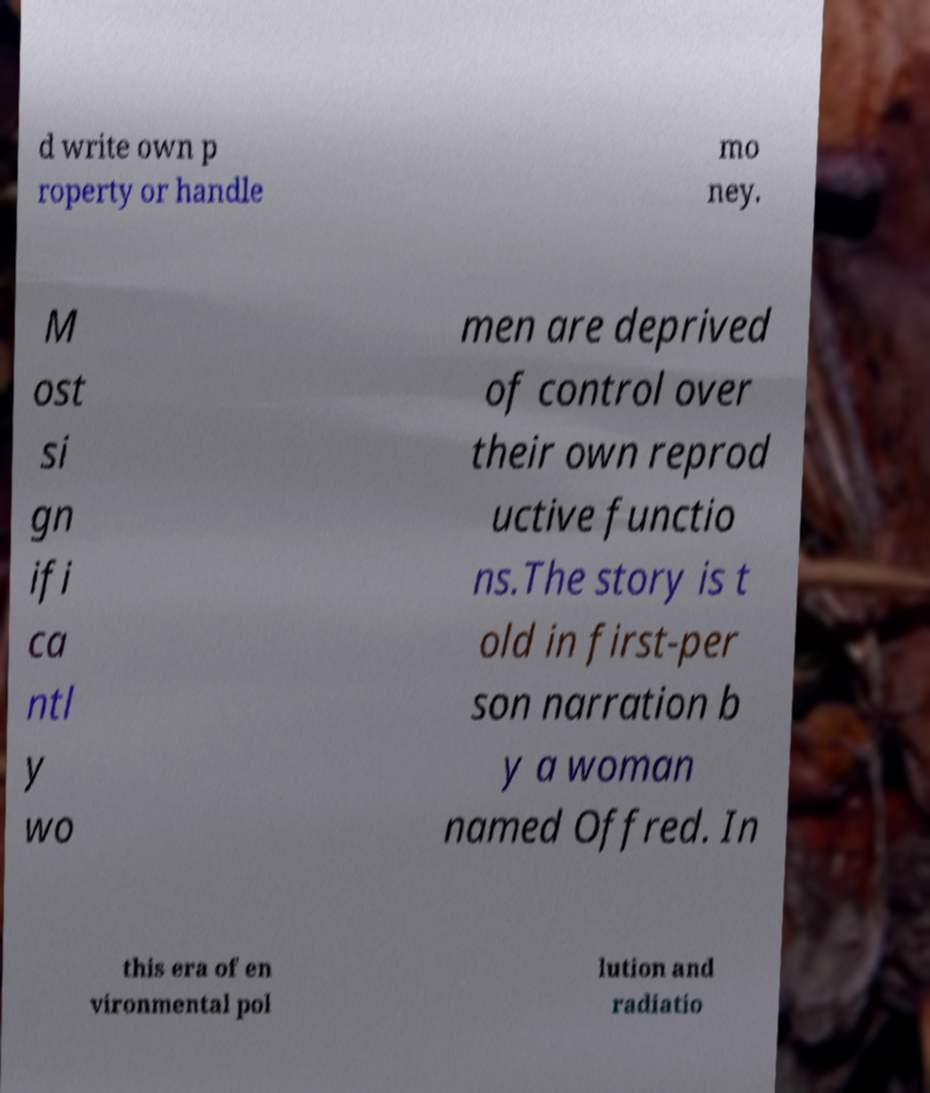What messages or text are displayed in this image? I need them in a readable, typed format. d write own p roperty or handle mo ney. M ost si gn ifi ca ntl y wo men are deprived of control over their own reprod uctive functio ns.The story is t old in first-per son narration b y a woman named Offred. In this era of en vironmental pol lution and radiatio 